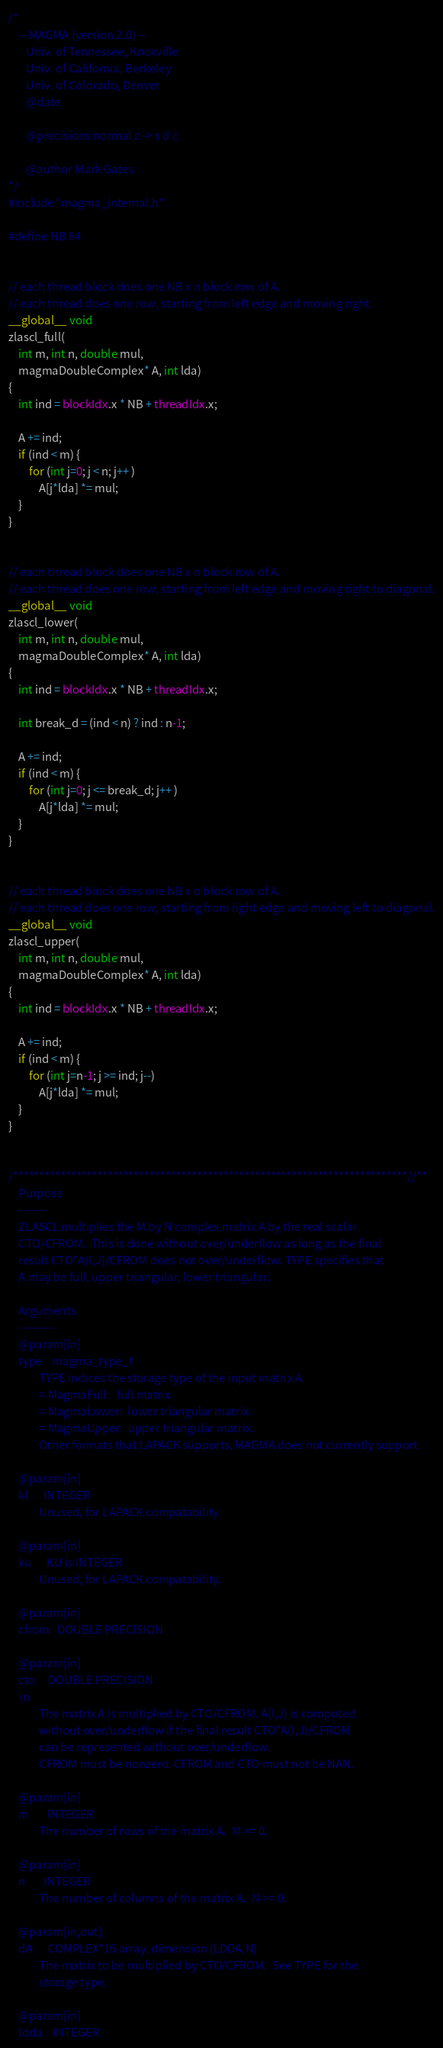Convert code to text. <code><loc_0><loc_0><loc_500><loc_500><_Cuda_>/*
    -- MAGMA (version 2.0) --
       Univ. of Tennessee, Knoxville
       Univ. of California, Berkeley
       Univ. of Colorado, Denver
       @date

       @precisions normal z -> s d c

       @author Mark Gates
*/
#include "magma_internal.h"

#define NB 64


// each thread block does one NB x n block row of A.
// each thread does one row, starting from left edge and moving right.
__global__ void
zlascl_full(
    int m, int n, double mul,
    magmaDoubleComplex* A, int lda)
{
    int ind = blockIdx.x * NB + threadIdx.x;

    A += ind;
    if (ind < m) {
        for (int j=0; j < n; j++ )
            A[j*lda] *= mul;
    }
}


// each thread block does one NB x n block row of A.
// each thread does one row, starting from left edge and moving right to diagonal.
__global__ void
zlascl_lower(
    int m, int n, double mul,
    magmaDoubleComplex* A, int lda)
{
    int ind = blockIdx.x * NB + threadIdx.x;

    int break_d = (ind < n) ? ind : n-1;

    A += ind;
    if (ind < m) {
        for (int j=0; j <= break_d; j++ )
            A[j*lda] *= mul;
    }
}


// each thread block does one NB x n block row of A.
// each thread does one row, starting from right edge and moving left to diagonal.
__global__ void
zlascl_upper(
    int m, int n, double mul,
    magmaDoubleComplex* A, int lda)
{
    int ind = blockIdx.x * NB + threadIdx.x;

    A += ind;
    if (ind < m) {
        for (int j=n-1; j >= ind; j--)
            A[j*lda] *= mul;
    }
}


/***************************************************************************//**
    Purpose
    -------
    ZLASCL multiplies the M by N complex matrix A by the real scalar
    CTO/CFROM.  This is done without over/underflow as long as the final
    result CTO*A(I,J)/CFROM does not over/underflow. TYPE specifies that
    A may be full, upper triangular, lower triangular.

    Arguments
    ---------
    @param[in]
    type    magma_type_t
            TYPE indices the storage type of the input matrix A.
            = MagmaFull:   full matrix.
            = MagmaLower:  lower triangular matrix.
            = MagmaUpper:  upper triangular matrix.
            Other formats that LAPACK supports, MAGMA does not currently support.

    @param[in]
    kl      INTEGER
            Unused, for LAPACK compatability.

    @param[in]
    ku      KU is INTEGER
            Unused, for LAPACK compatability.

    @param[in]
    cfrom   DOUBLE PRECISION

    @param[in]
    cto     DOUBLE PRECISION
    \n
            The matrix A is multiplied by CTO/CFROM. A(I,J) is computed
            without over/underflow if the final result CTO*A(I,J)/CFROM
            can be represented without over/underflow.
            CFROM must be nonzero. CFROM and CTO must not be NAN.

    @param[in]
    m       INTEGER
            The number of rows of the matrix A.  M >= 0.

    @param[in]
    n       INTEGER
            The number of columns of the matrix A.  N >= 0.

    @param[in,out]
    dA      COMPLEX*16 array, dimension (LDDA,N)
            The matrix to be multiplied by CTO/CFROM.  See TYPE for the
            storage type.

    @param[in]
    ldda    INTEGER</code> 